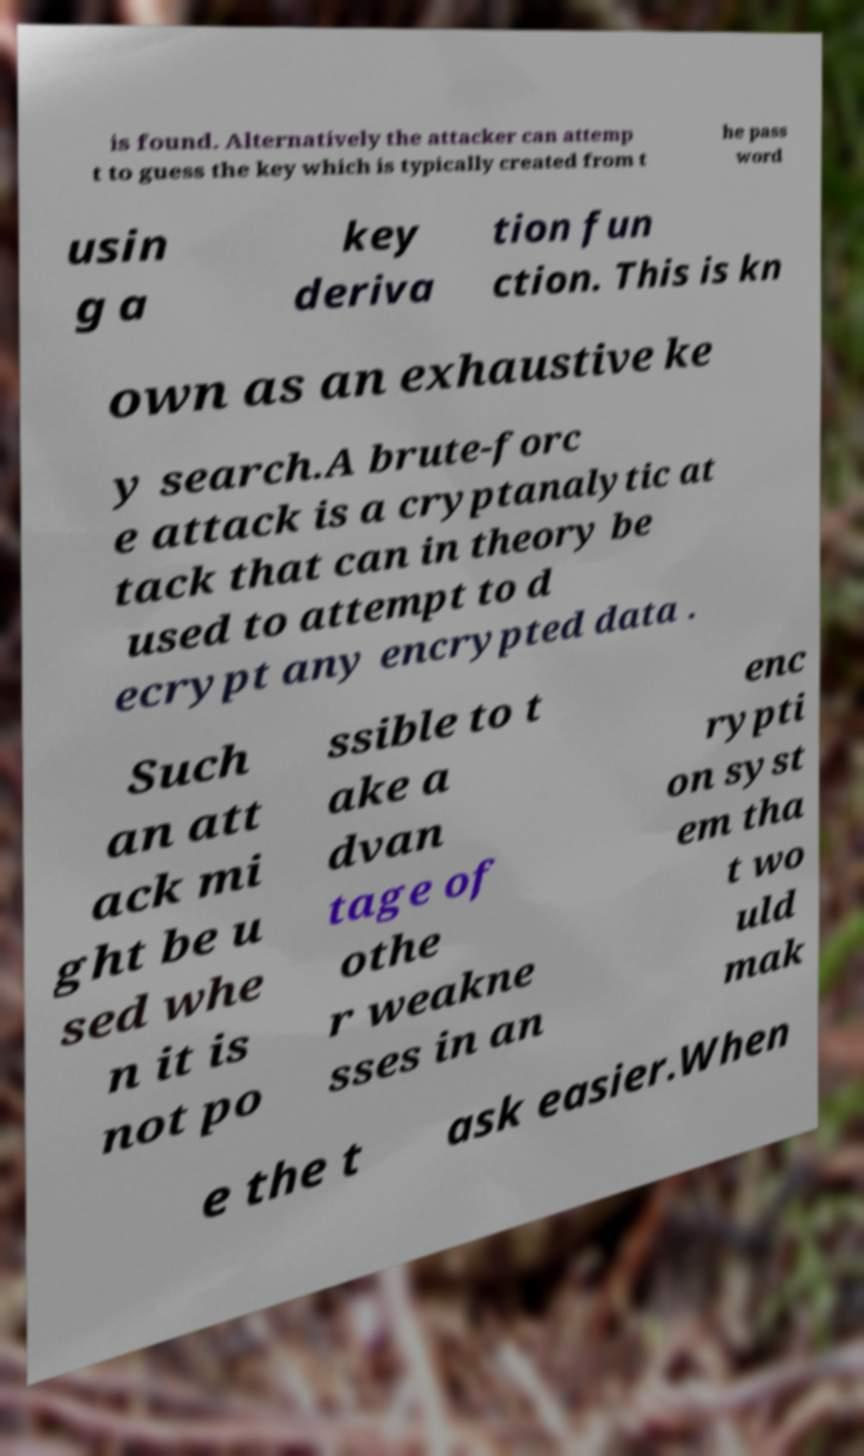Can you read and provide the text displayed in the image?This photo seems to have some interesting text. Can you extract and type it out for me? is found. Alternatively the attacker can attemp t to guess the key which is typically created from t he pass word usin g a key deriva tion fun ction. This is kn own as an exhaustive ke y search.A brute-forc e attack is a cryptanalytic at tack that can in theory be used to attempt to d ecrypt any encrypted data . Such an att ack mi ght be u sed whe n it is not po ssible to t ake a dvan tage of othe r weakne sses in an enc rypti on syst em tha t wo uld mak e the t ask easier.When 